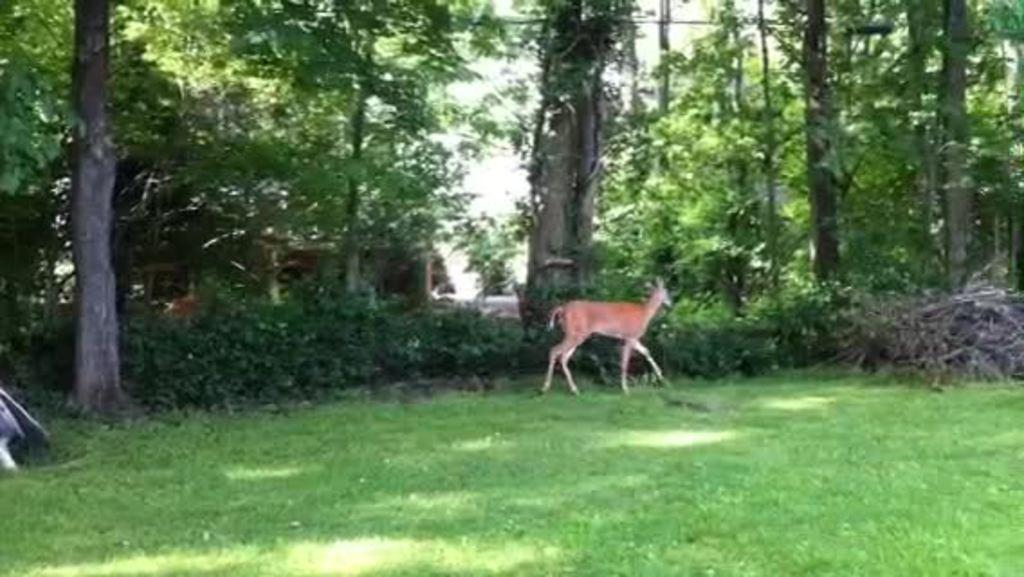What animal can be seen in the image? There is a deer in the image. What is the deer doing in the image? The deer is walking. What type of vegetation is at the bottom of the image? There is grass at the bottom of the image. What can be seen in the background of the image? There are trees in the background of the image. What statement does the deer make in the image? Deer cannot make statements, as they are animals and do not have the ability to communicate through language. 